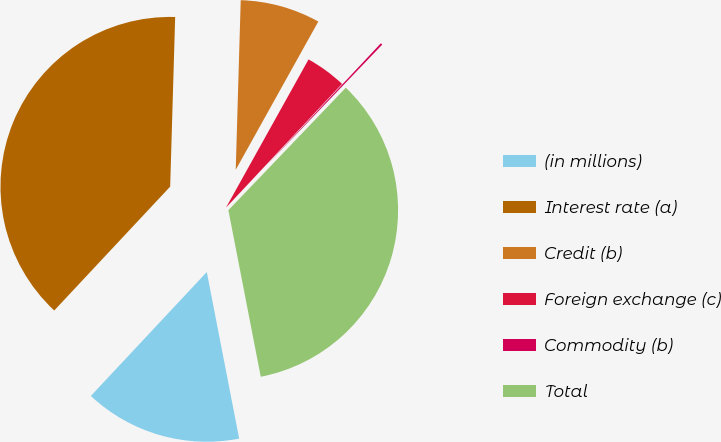<chart> <loc_0><loc_0><loc_500><loc_500><pie_chart><fcel>(in millions)<fcel>Interest rate (a)<fcel>Credit (b)<fcel>Foreign exchange (c)<fcel>Commodity (b)<fcel>Total<nl><fcel>15.03%<fcel>38.5%<fcel>7.62%<fcel>3.9%<fcel>0.18%<fcel>34.78%<nl></chart> 